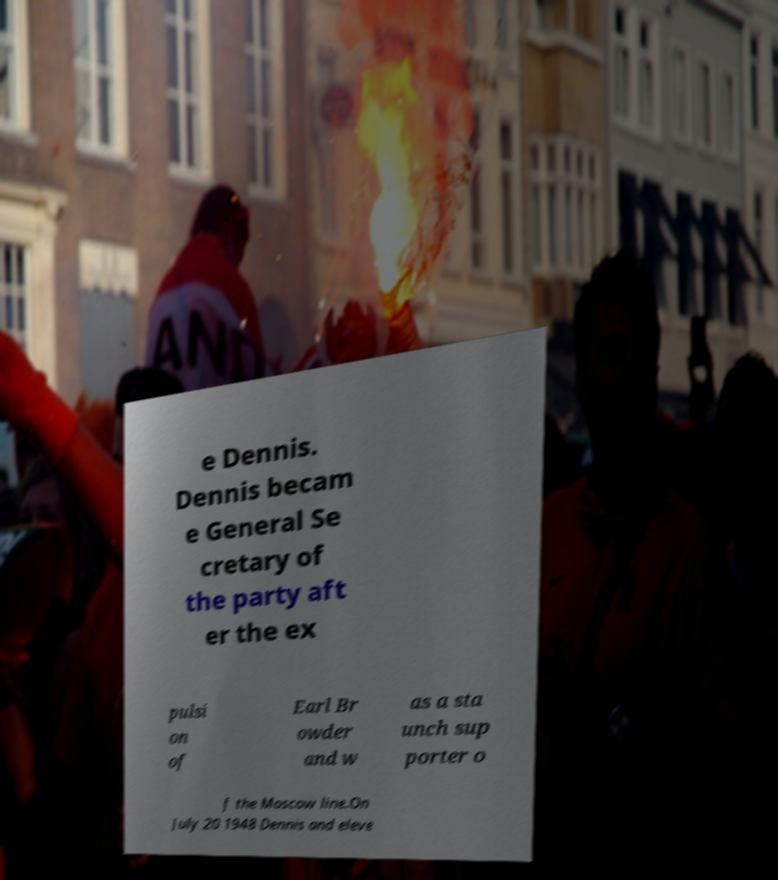Please identify and transcribe the text found in this image. e Dennis. Dennis becam e General Se cretary of the party aft er the ex pulsi on of Earl Br owder and w as a sta unch sup porter o f the Moscow line.On July 20 1948 Dennis and eleve 